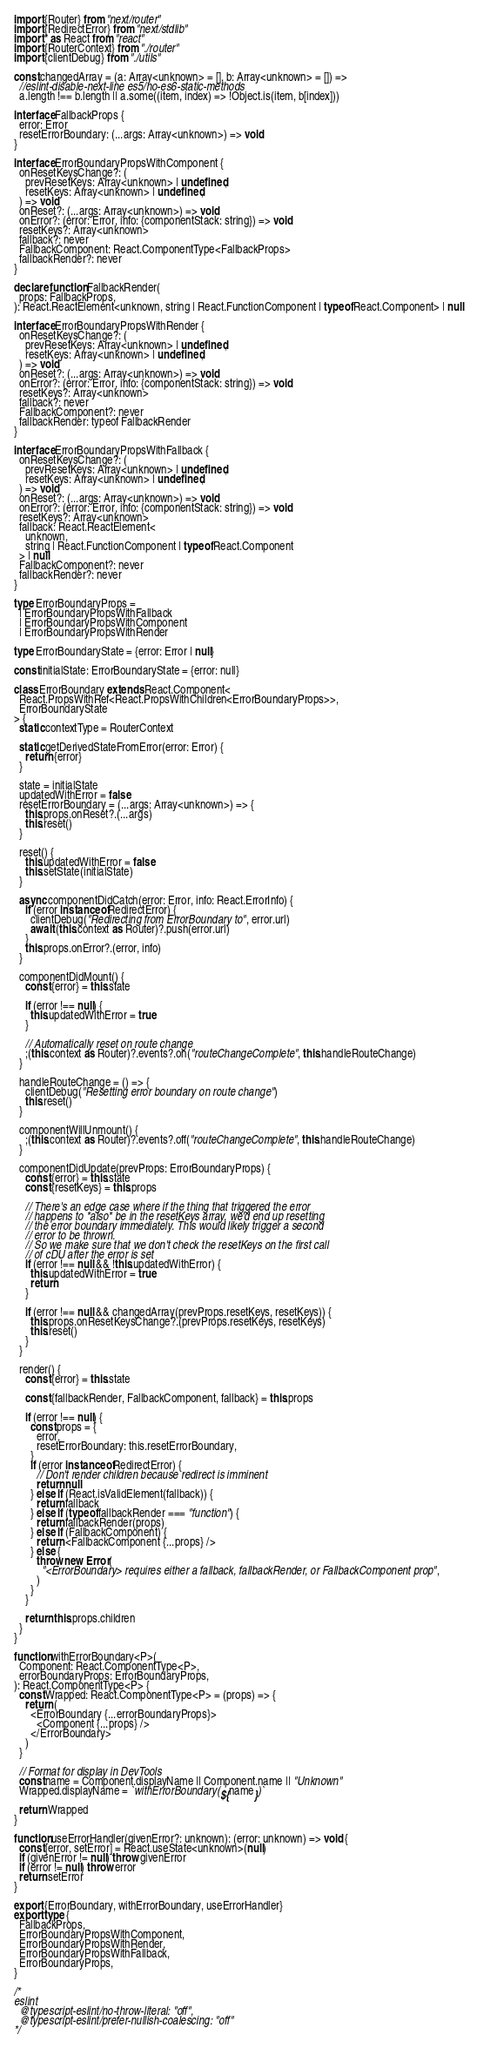Convert code to text. <code><loc_0><loc_0><loc_500><loc_500><_TypeScript_>import {Router} from "next/router"
import {RedirectError} from "next/stdlib"
import * as React from "react"
import {RouterContext} from "./router"
import {clientDebug} from "./utils"

const changedArray = (a: Array<unknown> = [], b: Array<unknown> = []) =>
  //eslint-disable-next-line es5/no-es6-static-methods
  a.length !== b.length || a.some((item, index) => !Object.is(item, b[index]))

interface FallbackProps {
  error: Error
  resetErrorBoundary: (...args: Array<unknown>) => void
}

interface ErrorBoundaryPropsWithComponent {
  onResetKeysChange?: (
    prevResetKeys: Array<unknown> | undefined,
    resetKeys: Array<unknown> | undefined,
  ) => void
  onReset?: (...args: Array<unknown>) => void
  onError?: (error: Error, info: {componentStack: string}) => void
  resetKeys?: Array<unknown>
  fallback?: never
  FallbackComponent: React.ComponentType<FallbackProps>
  fallbackRender?: never
}

declare function FallbackRender(
  props: FallbackProps,
): React.ReactElement<unknown, string | React.FunctionComponent | typeof React.Component> | null

interface ErrorBoundaryPropsWithRender {
  onResetKeysChange?: (
    prevResetKeys: Array<unknown> | undefined,
    resetKeys: Array<unknown> | undefined,
  ) => void
  onReset?: (...args: Array<unknown>) => void
  onError?: (error: Error, info: {componentStack: string}) => void
  resetKeys?: Array<unknown>
  fallback?: never
  FallbackComponent?: never
  fallbackRender: typeof FallbackRender
}

interface ErrorBoundaryPropsWithFallback {
  onResetKeysChange?: (
    prevResetKeys: Array<unknown> | undefined,
    resetKeys: Array<unknown> | undefined,
  ) => void
  onReset?: (...args: Array<unknown>) => void
  onError?: (error: Error, info: {componentStack: string}) => void
  resetKeys?: Array<unknown>
  fallback: React.ReactElement<
    unknown,
    string | React.FunctionComponent | typeof React.Component
  > | null
  FallbackComponent?: never
  fallbackRender?: never
}

type ErrorBoundaryProps =
  | ErrorBoundaryPropsWithFallback
  | ErrorBoundaryPropsWithComponent
  | ErrorBoundaryPropsWithRender

type ErrorBoundaryState = {error: Error | null}

const initialState: ErrorBoundaryState = {error: null}

class ErrorBoundary extends React.Component<
  React.PropsWithRef<React.PropsWithChildren<ErrorBoundaryProps>>,
  ErrorBoundaryState
> {
  static contextType = RouterContext

  static getDerivedStateFromError(error: Error) {
    return {error}
  }

  state = initialState
  updatedWithError = false
  resetErrorBoundary = (...args: Array<unknown>) => {
    this.props.onReset?.(...args)
    this.reset()
  }

  reset() {
    this.updatedWithError = false
    this.setState(initialState)
  }

  async componentDidCatch(error: Error, info: React.ErrorInfo) {
    if (error instanceof RedirectError) {
      clientDebug("Redirecting from ErrorBoundary to", error.url)
      await (this.context as Router)?.push(error.url)
    }
    this.props.onError?.(error, info)
  }

  componentDidMount() {
    const {error} = this.state

    if (error !== null) {
      this.updatedWithError = true
    }

    // Automatically reset on route change
    ;(this.context as Router)?.events?.on("routeChangeComplete", this.handleRouteChange)
  }

  handleRouteChange = () => {
    clientDebug("Resetting error boundary on route change")
    this.reset()
  }

  componentWillUnmount() {
    ;(this.context as Router)?.events?.off("routeChangeComplete", this.handleRouteChange)
  }

  componentDidUpdate(prevProps: ErrorBoundaryProps) {
    const {error} = this.state
    const {resetKeys} = this.props

    // There's an edge case where if the thing that triggered the error
    // happens to *also* be in the resetKeys array, we'd end up resetting
    // the error boundary immediately. This would likely trigger a second
    // error to be thrown.
    // So we make sure that we don't check the resetKeys on the first call
    // of cDU after the error is set
    if (error !== null && !this.updatedWithError) {
      this.updatedWithError = true
      return
    }

    if (error !== null && changedArray(prevProps.resetKeys, resetKeys)) {
      this.props.onResetKeysChange?.(prevProps.resetKeys, resetKeys)
      this.reset()
    }
  }

  render() {
    const {error} = this.state

    const {fallbackRender, FallbackComponent, fallback} = this.props

    if (error !== null) {
      const props = {
        error,
        resetErrorBoundary: this.resetErrorBoundary,
      }
      if (error instanceof RedirectError) {
        // Don't render children because redirect is imminent
        return null
      } else if (React.isValidElement(fallback)) {
        return fallback
      } else if (typeof fallbackRender === "function") {
        return fallbackRender(props)
      } else if (FallbackComponent) {
        return <FallbackComponent {...props} />
      } else {
        throw new Error(
          "<ErrorBoundary> requires either a fallback, fallbackRender, or FallbackComponent prop",
        )
      }
    }

    return this.props.children
  }
}

function withErrorBoundary<P>(
  Component: React.ComponentType<P>,
  errorBoundaryProps: ErrorBoundaryProps,
): React.ComponentType<P> {
  const Wrapped: React.ComponentType<P> = (props) => {
    return (
      <ErrorBoundary {...errorBoundaryProps}>
        <Component {...props} />
      </ErrorBoundary>
    )
  }

  // Format for display in DevTools
  const name = Component.displayName || Component.name || "Unknown"
  Wrapped.displayName = `withErrorBoundary(${name})`

  return Wrapped
}

function useErrorHandler(givenError?: unknown): (error: unknown) => void {
  const [error, setError] = React.useState<unknown>(null)
  if (givenError != null) throw givenError
  if (error != null) throw error
  return setError
}

export {ErrorBoundary, withErrorBoundary, useErrorHandler}
export type {
  FallbackProps,
  ErrorBoundaryPropsWithComponent,
  ErrorBoundaryPropsWithRender,
  ErrorBoundaryPropsWithFallback,
  ErrorBoundaryProps,
}

/*
eslint
  @typescript-eslint/no-throw-literal: "off",
  @typescript-eslint/prefer-nullish-coalescing: "off"
*/
</code> 